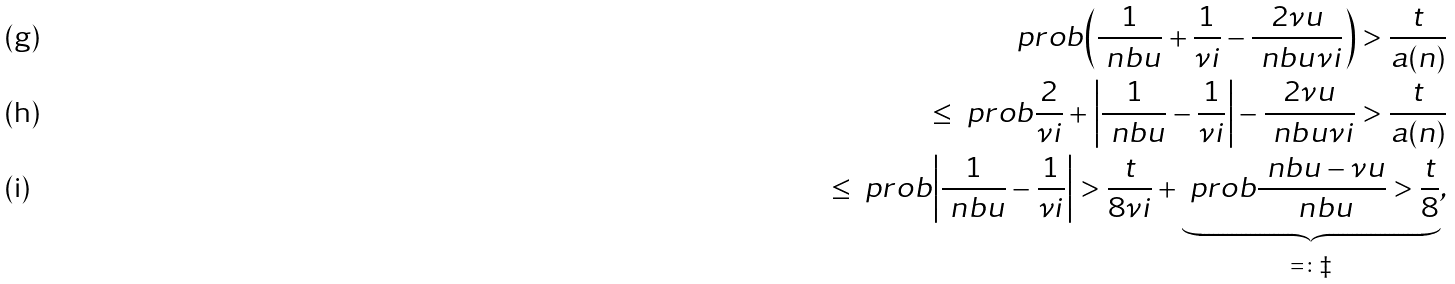Convert formula to latex. <formula><loc_0><loc_0><loc_500><loc_500>\ p r o b { \left ( \frac { 1 } { \ n b u } + \frac { 1 } { \nu i } - \frac { 2 \nu u } { \ n b u \nu i } \right ) > \frac { t } { a ( n ) } } \\ \leq \ p r o b { \frac { 2 } { \nu i } + \left | \frac { 1 } { \ n b u } - \frac { 1 } { \nu i } \right | - \frac { 2 \nu u } { \ n b u \nu i } > \frac { t } { a ( n ) } } \\ \leq \ p r o b { \left | \frac { 1 } { \ n b u } - \frac { 1 } { \nu i } \right | > \frac { t } { 8 \nu i } } + \underbrace { \ p r o b { \frac { \ n b u - \nu u } { \ n b u } > \frac { t } { 8 } } } _ { = \colon \ddag } ,</formula> 